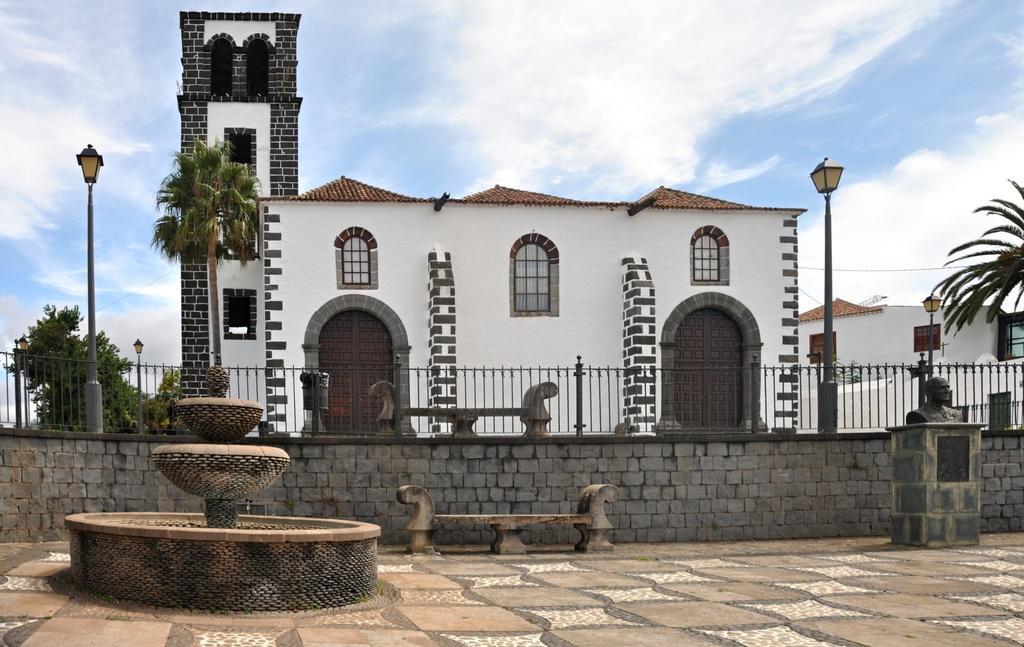Could you give a brief overview of what you see in this image? In this image there is a fence. Before it there is a bench on the floor. Left side there is a fountain. Right side there is a statue on the pillar. Behind the fence there are few street lights. There are few buildings. Background there are few trees. Top of the image there is sky with some clouds. 